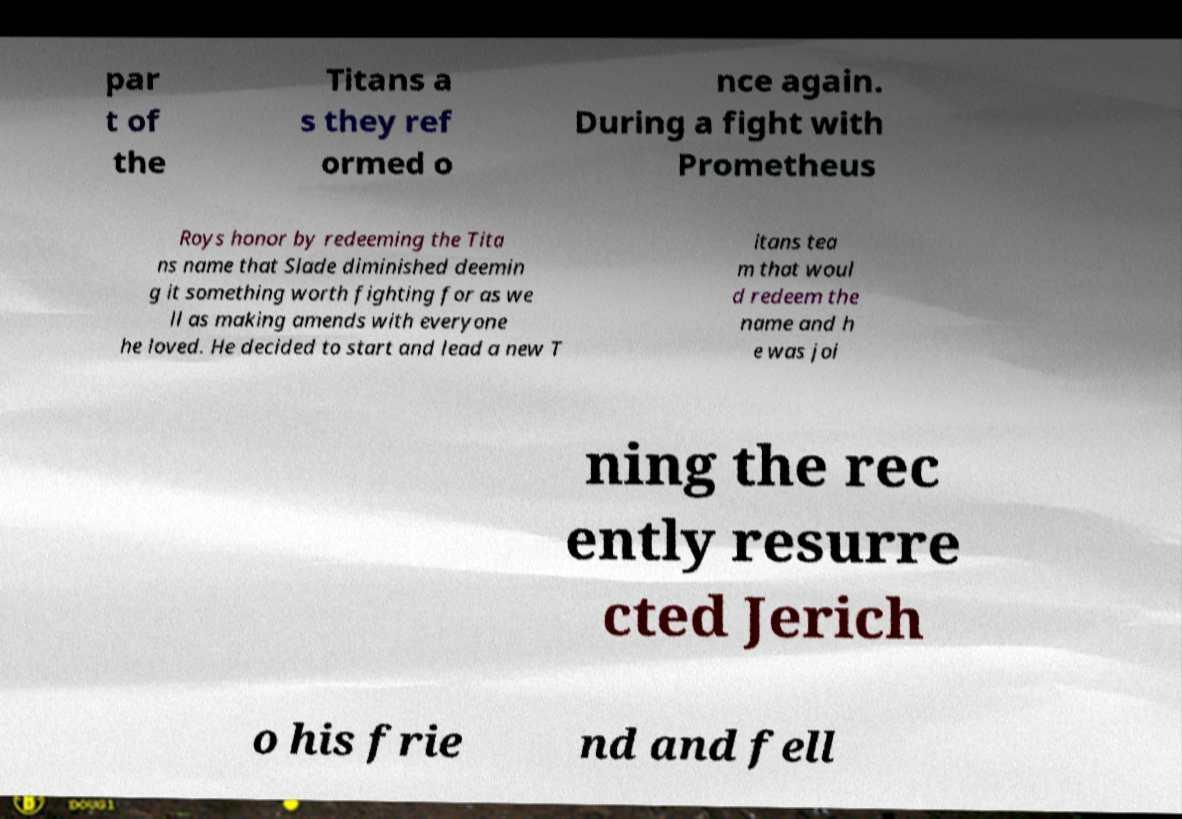There's text embedded in this image that I need extracted. Can you transcribe it verbatim? par t of the Titans a s they ref ormed o nce again. During a fight with Prometheus Roys honor by redeeming the Tita ns name that Slade diminished deemin g it something worth fighting for as we ll as making amends with everyone he loved. He decided to start and lead a new T itans tea m that woul d redeem the name and h e was joi ning the rec ently resurre cted Jerich o his frie nd and fell 